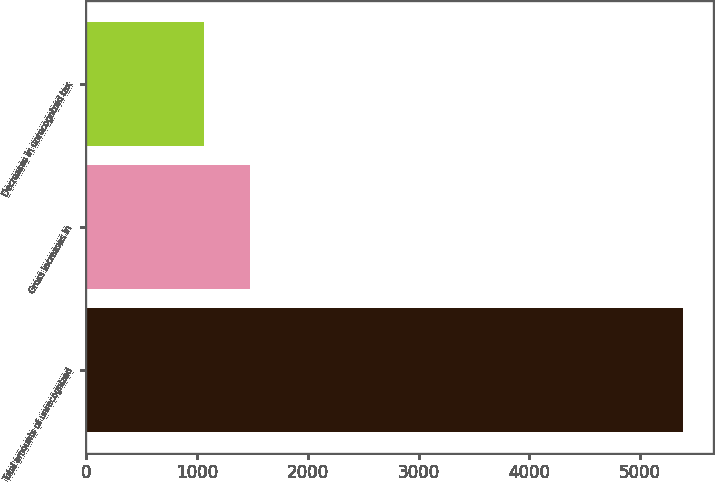<chart> <loc_0><loc_0><loc_500><loc_500><bar_chart><fcel>Total amounts of unrecognized<fcel>Gross increases in<fcel>Decreases in unrecognized tax<nl><fcel>5384.1<fcel>1476.1<fcel>1068<nl></chart> 